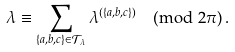<formula> <loc_0><loc_0><loc_500><loc_500>\lambda \equiv \sum _ { \{ a , b , c \} \in { \mathcal { T } } _ { \lambda } } \lambda ^ { ( \{ a , b , c \} ) } \pmod { 2 \pi } \, .</formula> 